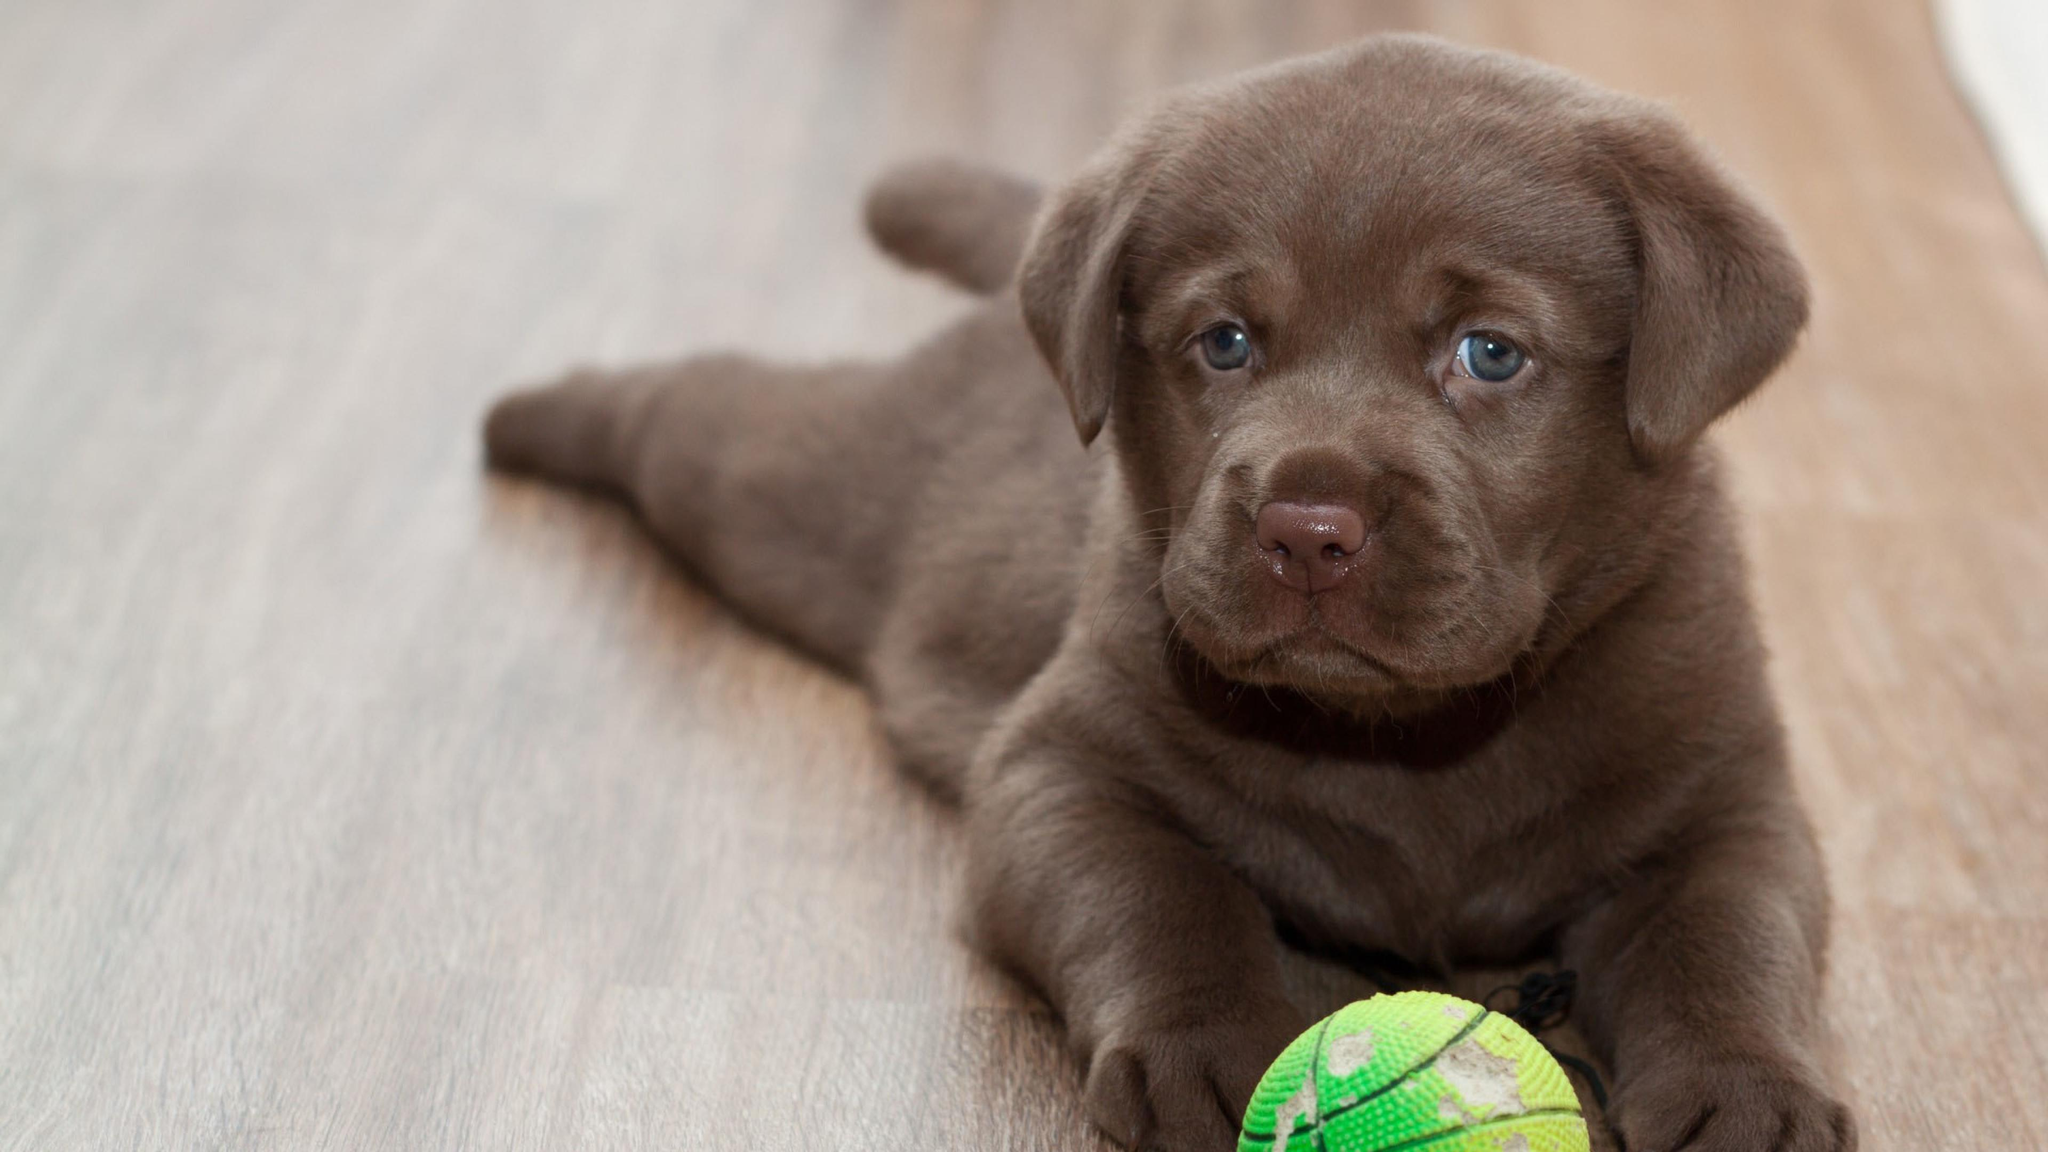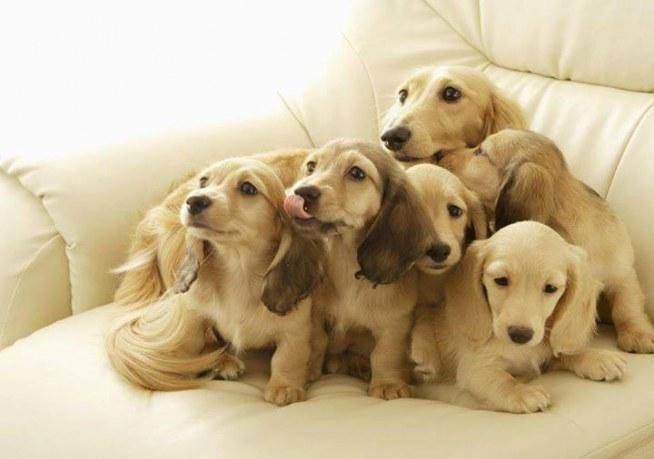The first image is the image on the left, the second image is the image on the right. Examine the images to the left and right. Is the description "In 1 of the images, 1 dog is leaning over the edge of a wooden box." accurate? Answer yes or no. No. The first image is the image on the left, the second image is the image on the right. For the images displayed, is the sentence "In one image, a puppy is leaning over a wooden ledge with only its head and front paws visible." factually correct? Answer yes or no. No. 